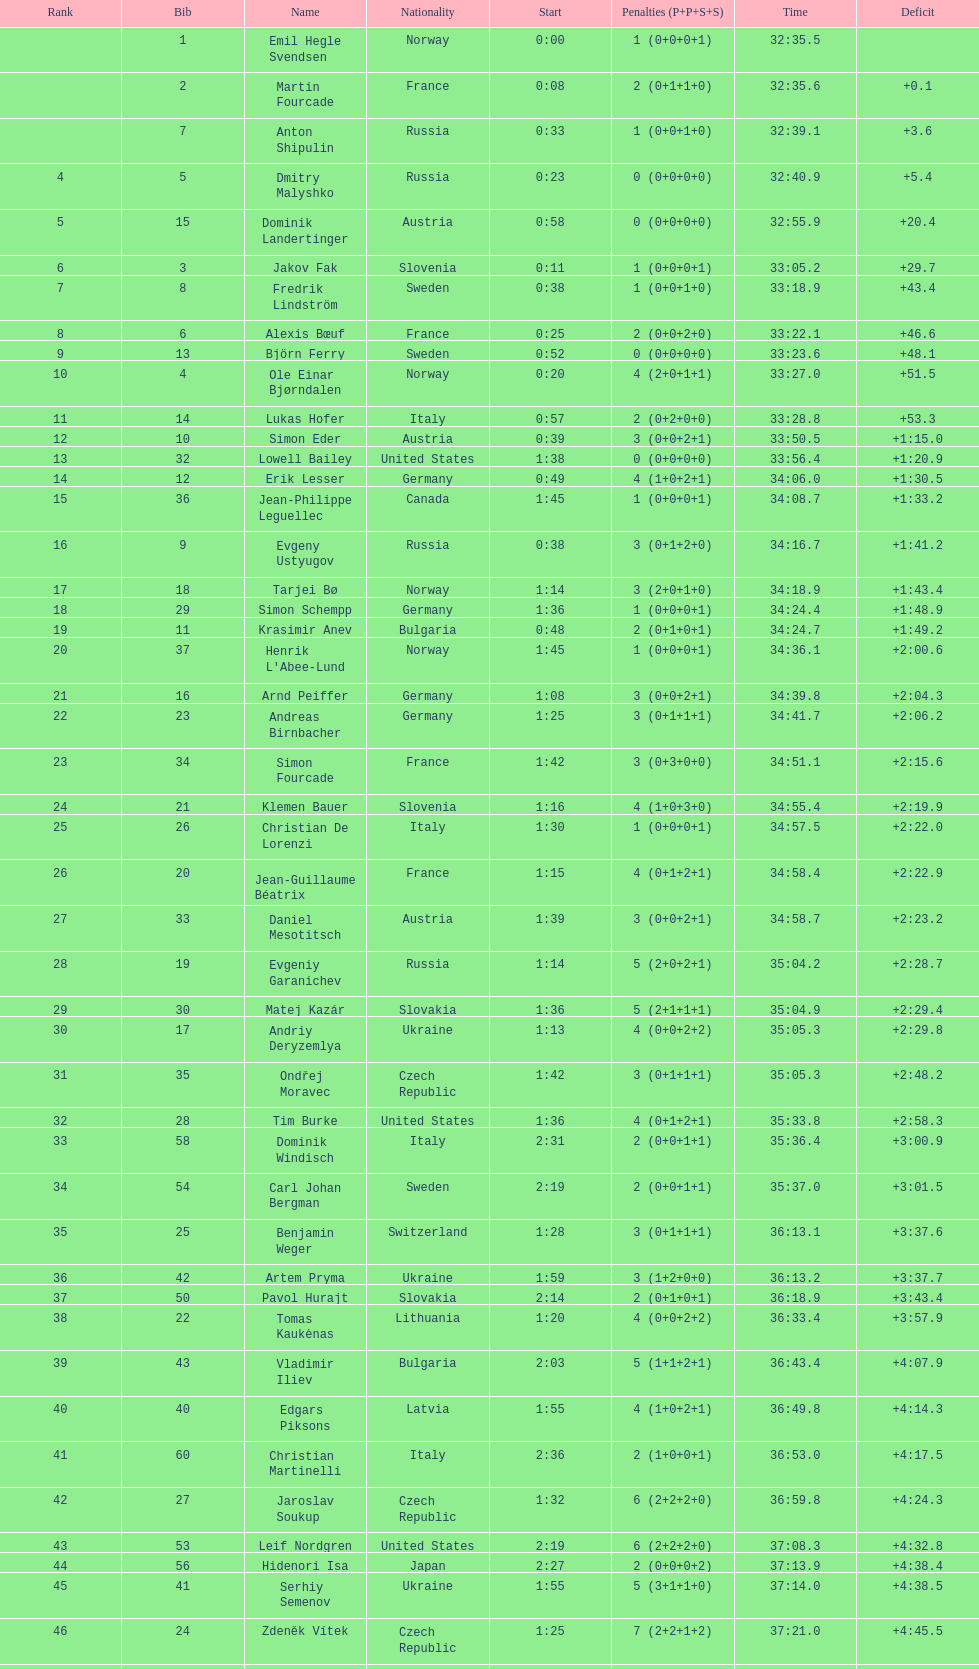What is the biggest punishment? 10. 